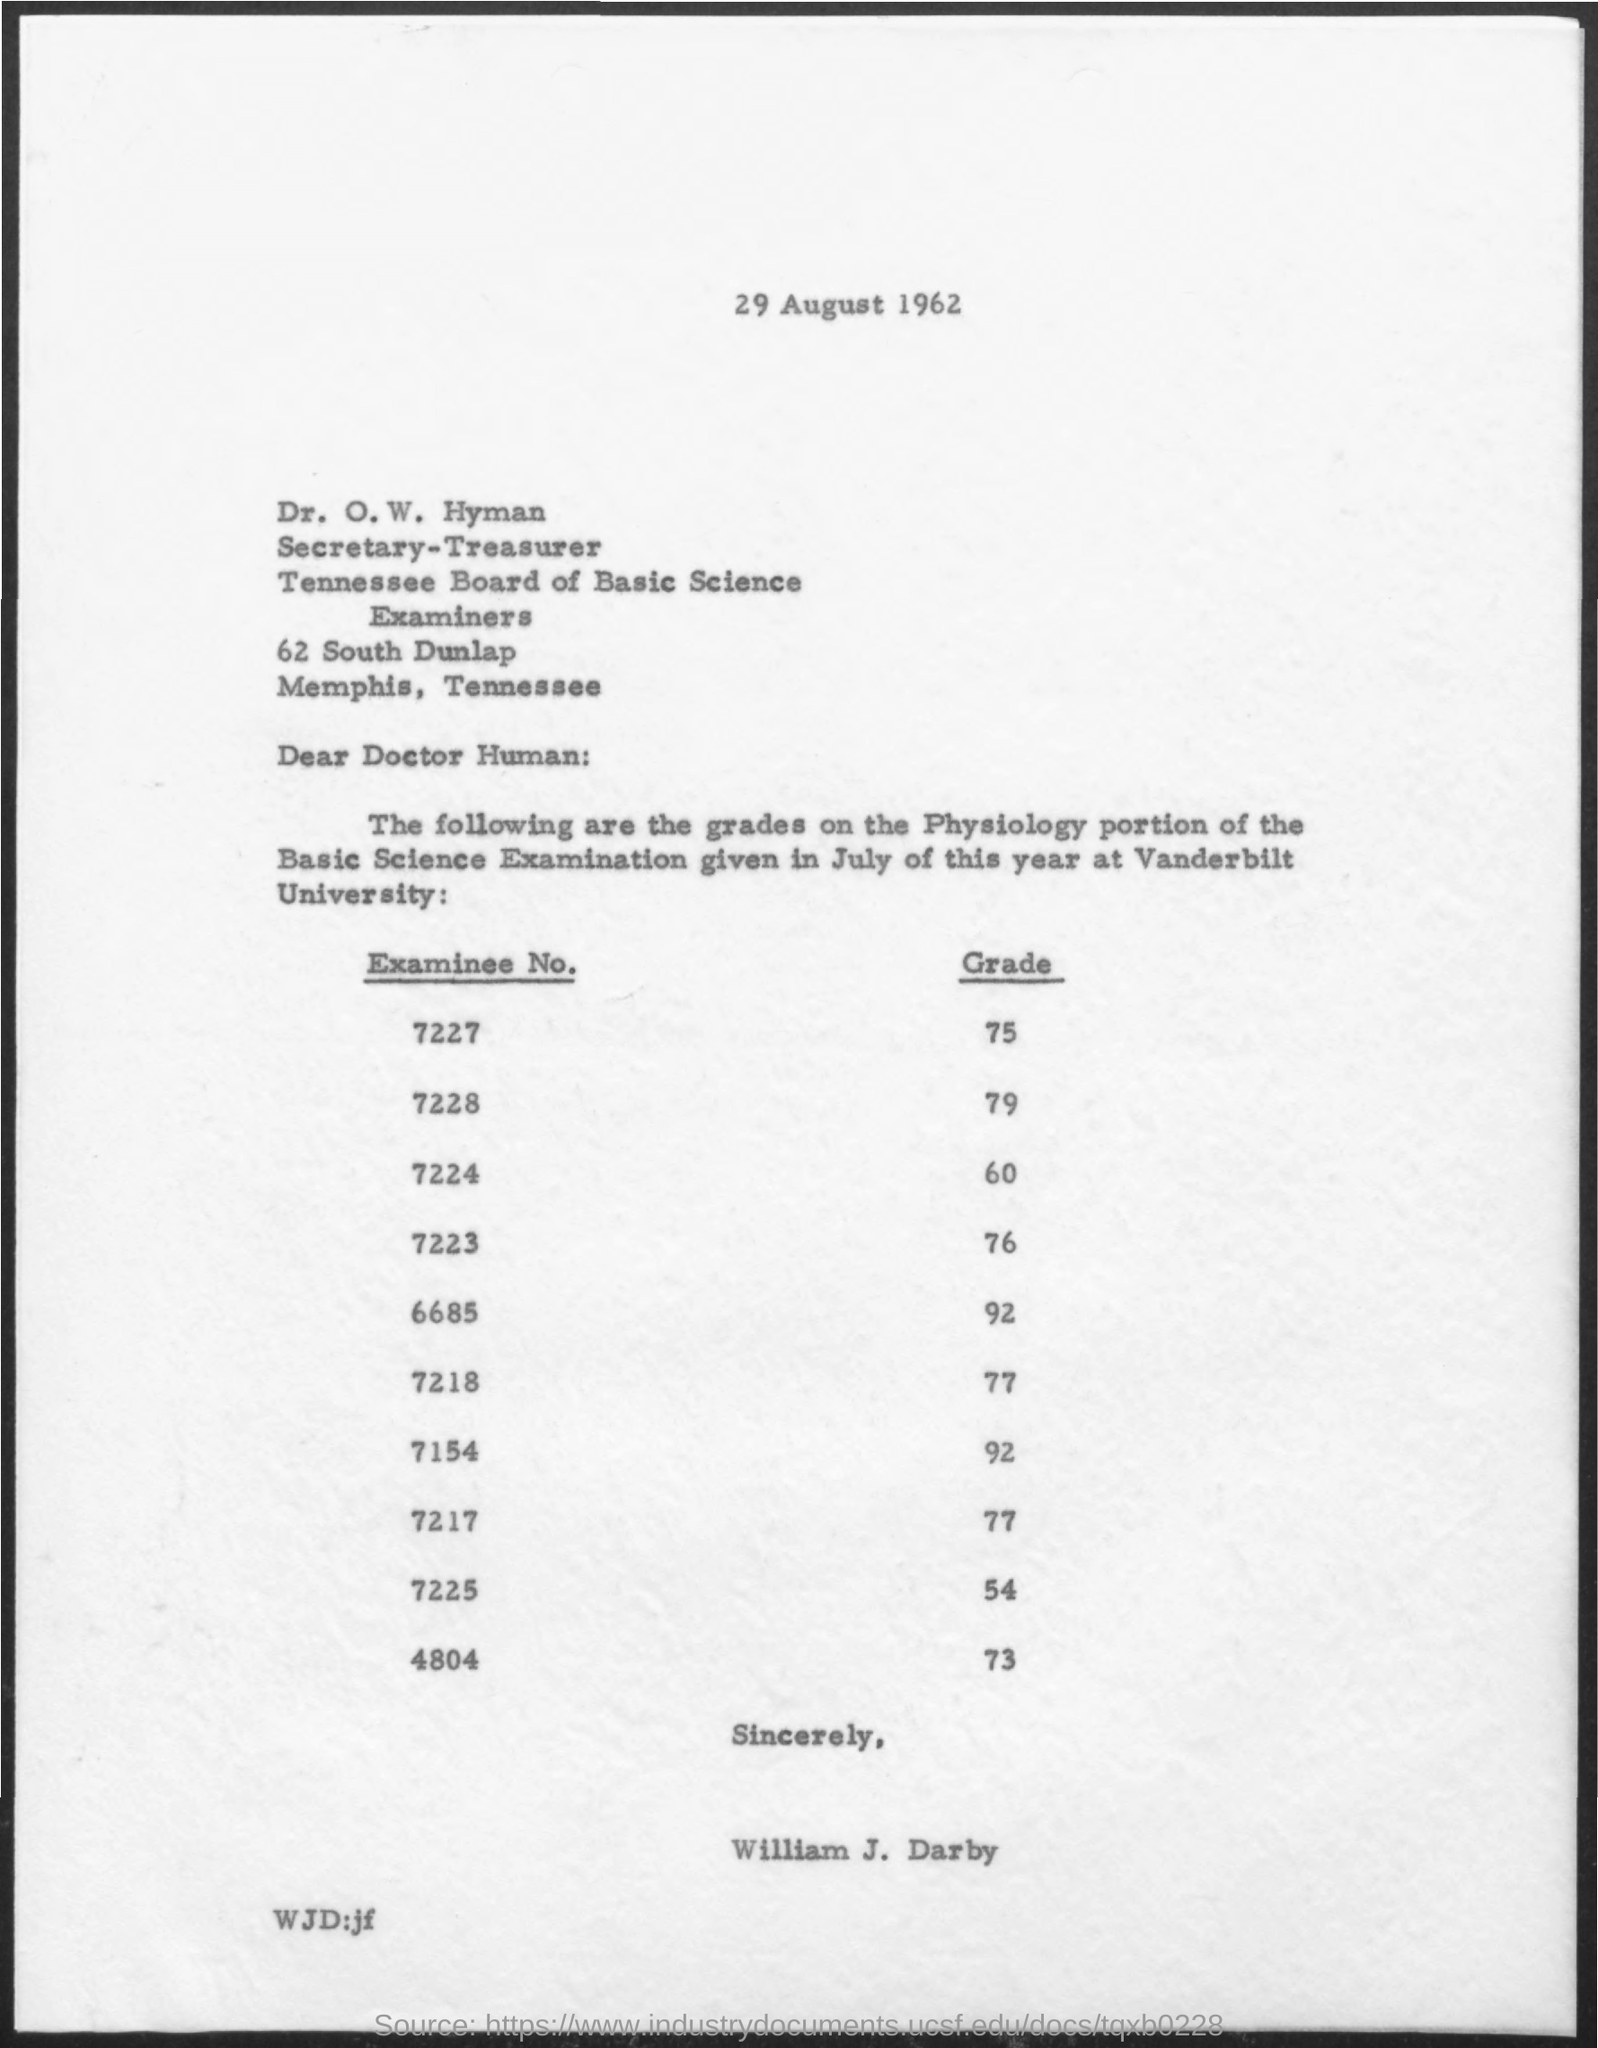Point out several critical features in this image. The examinee's grade for No. 6685 is 92. The examinee's grade is 79%. The grade for examinee number 7224 is 60. The examinee's grade is 77.. What is the grade for examinee number 7223? It is 76.. 